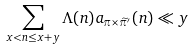Convert formula to latex. <formula><loc_0><loc_0><loc_500><loc_500>\sum _ { x < n \leq x + y } \Lambda ( n ) a _ { \pi \times \widetilde { \pi } ^ { \prime } } ( n ) \ll y</formula> 